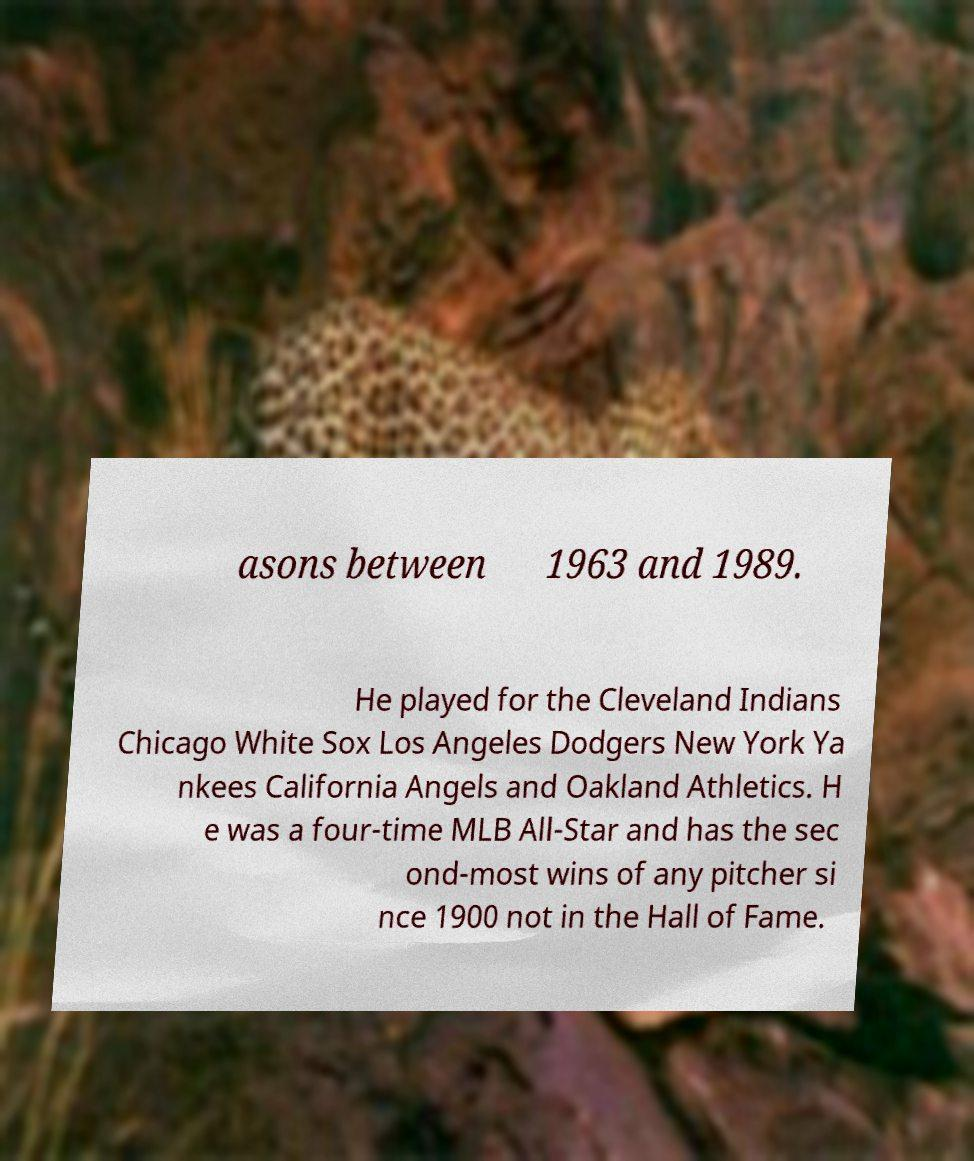Please identify and transcribe the text found in this image. asons between 1963 and 1989. He played for the Cleveland Indians Chicago White Sox Los Angeles Dodgers New York Ya nkees California Angels and Oakland Athletics. H e was a four-time MLB All-Star and has the sec ond-most wins of any pitcher si nce 1900 not in the Hall of Fame. 